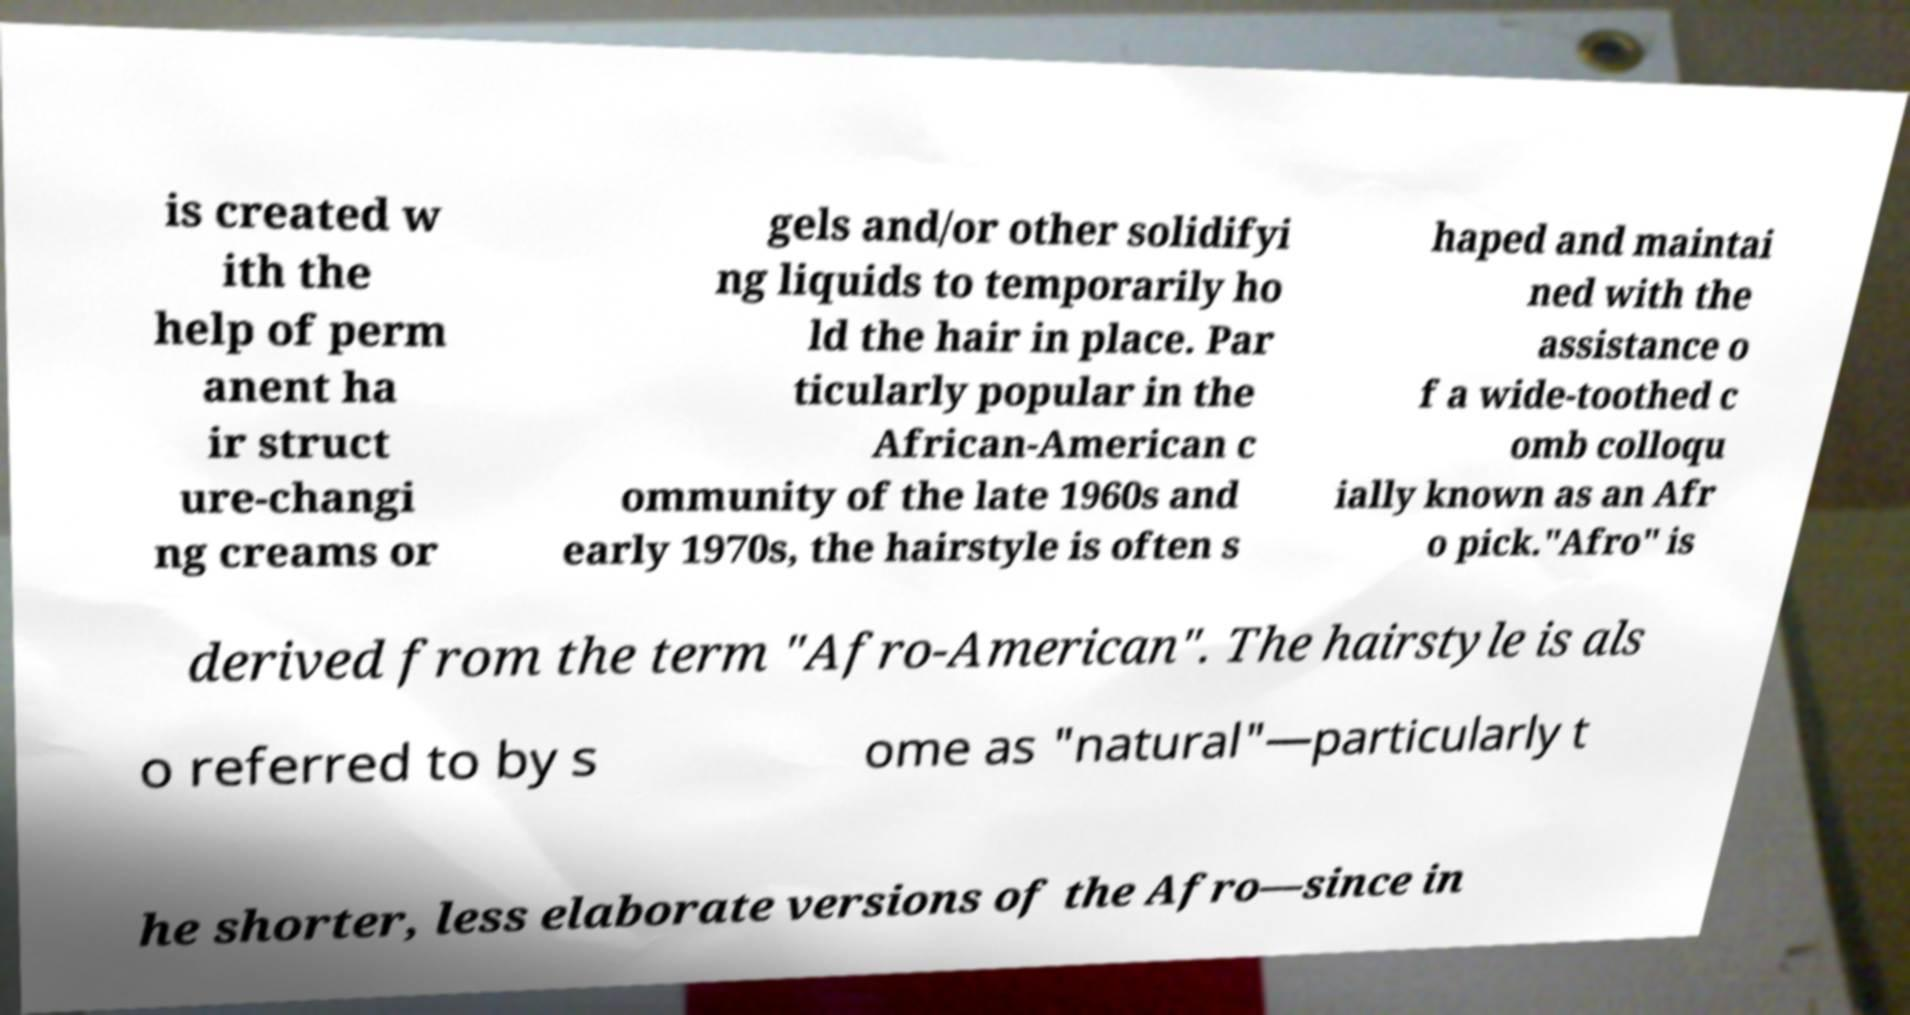Could you assist in decoding the text presented in this image and type it out clearly? is created w ith the help of perm anent ha ir struct ure-changi ng creams or gels and/or other solidifyi ng liquids to temporarily ho ld the hair in place. Par ticularly popular in the African-American c ommunity of the late 1960s and early 1970s, the hairstyle is often s haped and maintai ned with the assistance o f a wide-toothed c omb colloqu ially known as an Afr o pick."Afro" is derived from the term "Afro-American". The hairstyle is als o referred to by s ome as "natural"—particularly t he shorter, less elaborate versions of the Afro—since in 